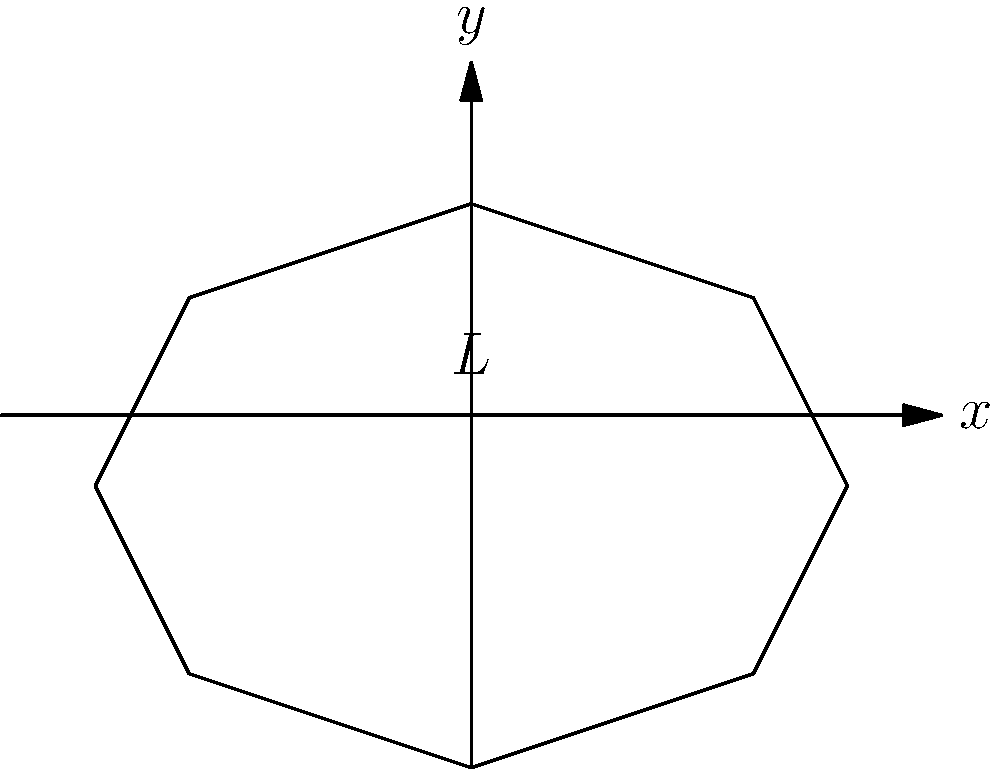A violinist is studying the acoustics of their instrument. They observe that the fundamental frequency of a standing wave inside the violin's body corresponds to a wavelength twice the length of the violin's body. If the speed of sound in air is 343 m/s and the length of the violin's body (L) is 0.35 m, what is the fundamental frequency of the standing wave? To solve this problem, we'll follow these steps:

1) First, recall the relationship between wavelength ($\lambda$), frequency ($f$), and wave speed ($v$):

   $$v = f\lambda$$

2) We're told that the wavelength of the fundamental frequency is twice the length of the violin's body. So:

   $$\lambda = 2L = 2 * 0.35 \text{ m} = 0.7 \text{ m}$$

3) We're also given the speed of sound in air:

   $$v = 343 \text{ m/s}$$

4) Now we can substitute these values into our wave equation:

   $$343 \text{ m/s} = f * 0.7 \text{ m}$$

5) Solving for $f$:

   $$f = \frac{343 \text{ m/s}}{0.7 \text{ m}} = 490 \text{ Hz}$$

Therefore, the fundamental frequency of the standing wave is 490 Hz.
Answer: 490 Hz 